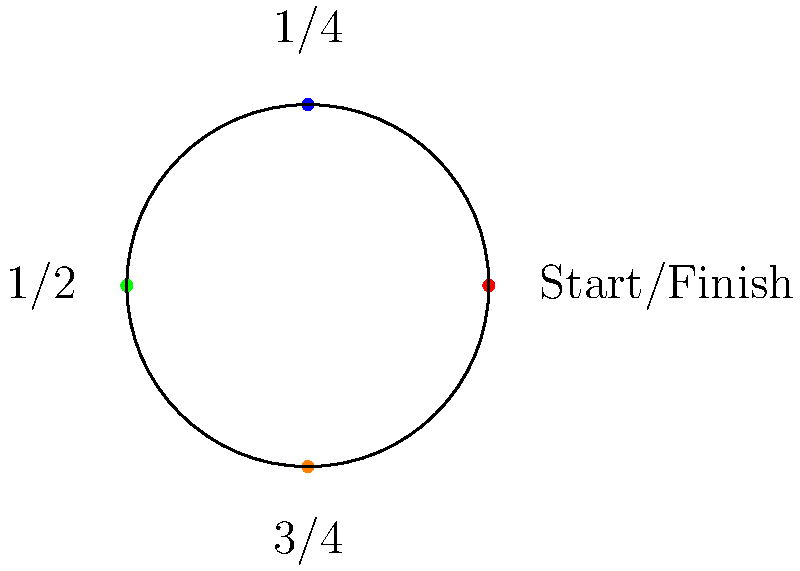A race car completes laps around a circular track. The track is divided into four equal positions: Start/Finish, 1/4, 1/2, and 3/4. If the car's position after each lap forms a cyclic group, what is the order of this group? To determine the order of the cyclic group, we need to follow these steps:

1. Identify the elements of the group:
   The elements are the possible positions of the car after each lap.
   These are: Start/Finish, 1/4, 1/2, and 3/4.

2. Understand the group operation:
   The operation is the movement of the car around the track.
   One full lap moves the car from its current position back to the same position.

3. Determine the generator of the group:
   The generator is the smallest movement that, when repeated, can produce all elements.
   In this case, moving 1/4 of the track is the generator.

4. Count the number of unique elements:
   Start/Finish -> 1/4 -> 1/2 -> 3/4 -> Start/Finish
   There are 4 unique positions before returning to the start.

5. Conclude:
   The order of a cyclic group is the number of unique elements generated before returning to the identity element.
   In this case, there are 4 unique elements.

Therefore, the order of this cyclic group is 4.
Answer: 4 